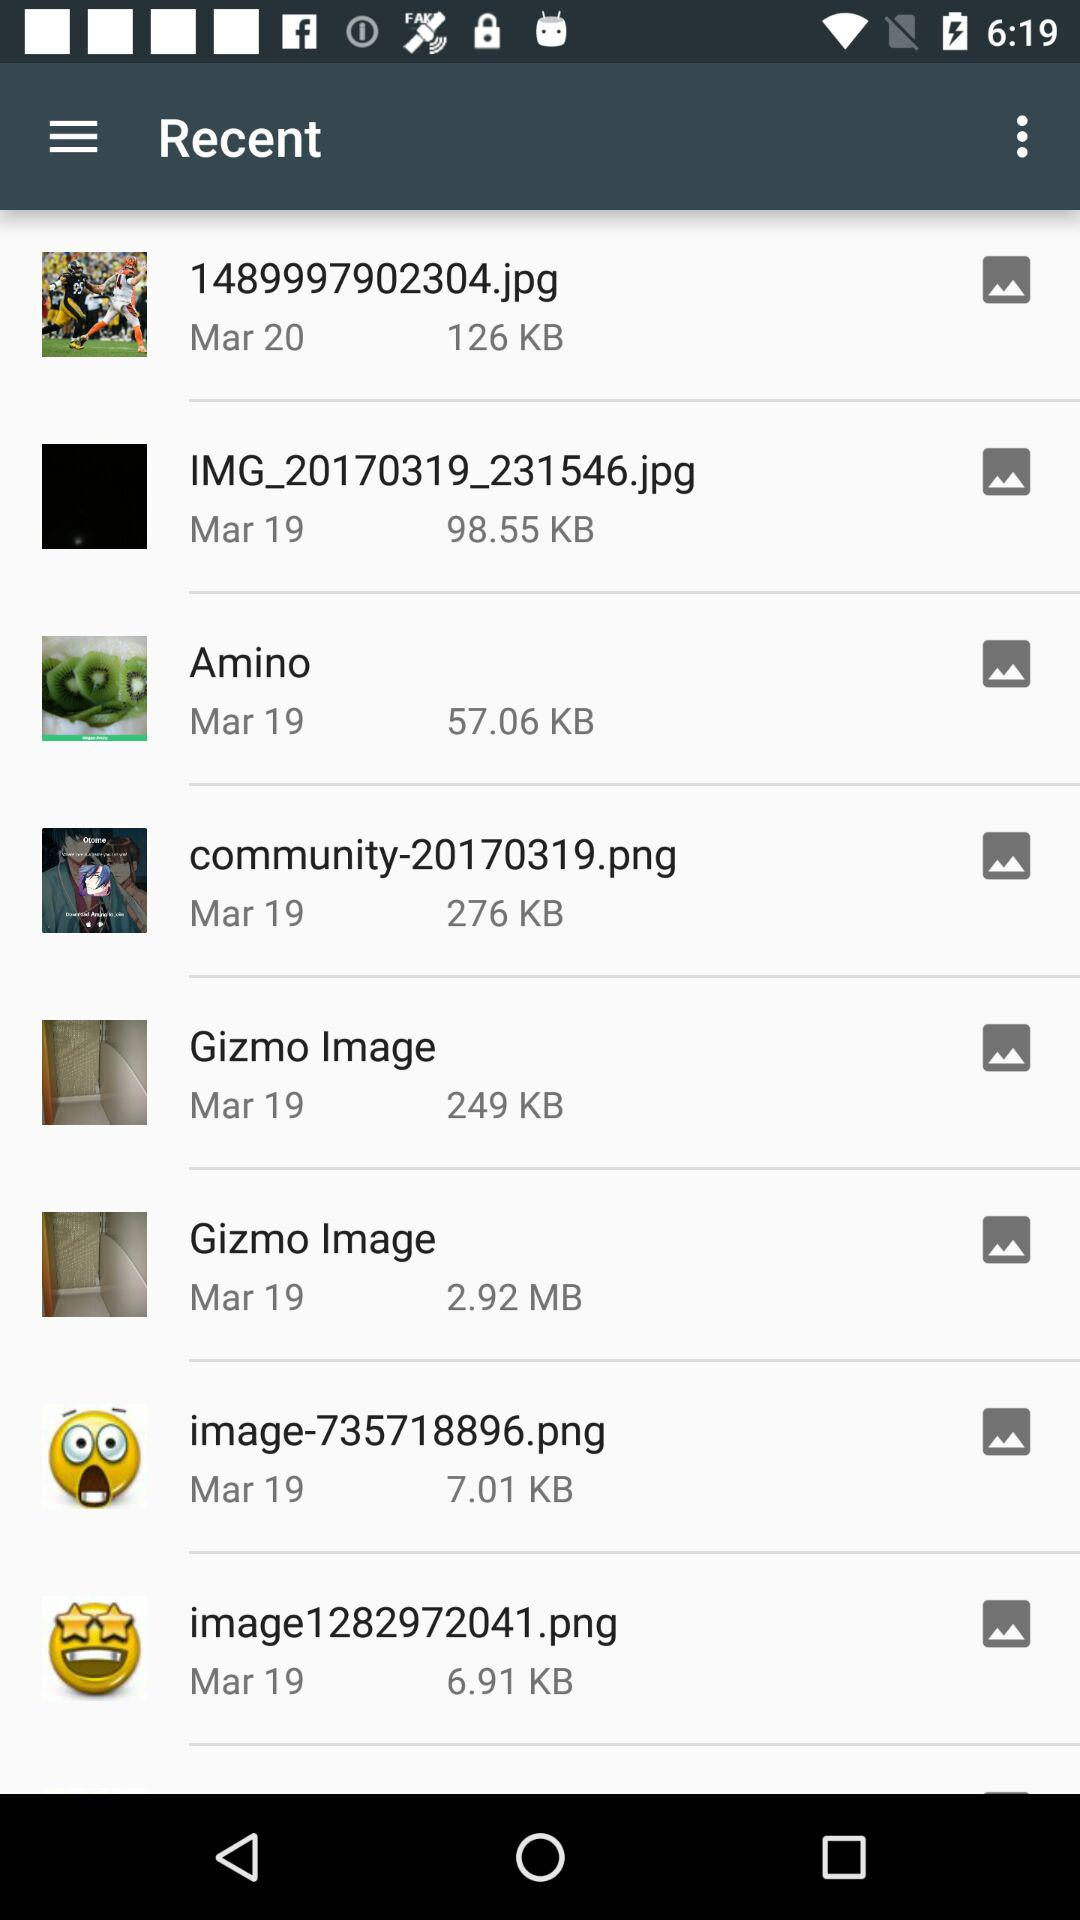What is the date of the "Amino" file? The date of the "Amino" file is March 19. 